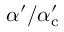<formula> <loc_0><loc_0><loc_500><loc_500>\alpha ^ { \prime } / \alpha _ { c } ^ { \prime }</formula> 